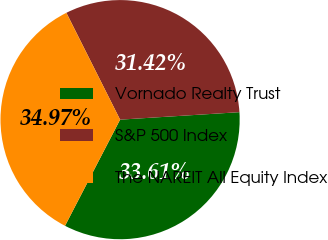Convert chart. <chart><loc_0><loc_0><loc_500><loc_500><pie_chart><fcel>Vornado Realty Trust<fcel>S&P 500 Index<fcel>The NAREIT All Equity Index<nl><fcel>33.61%<fcel>31.42%<fcel>34.97%<nl></chart> 